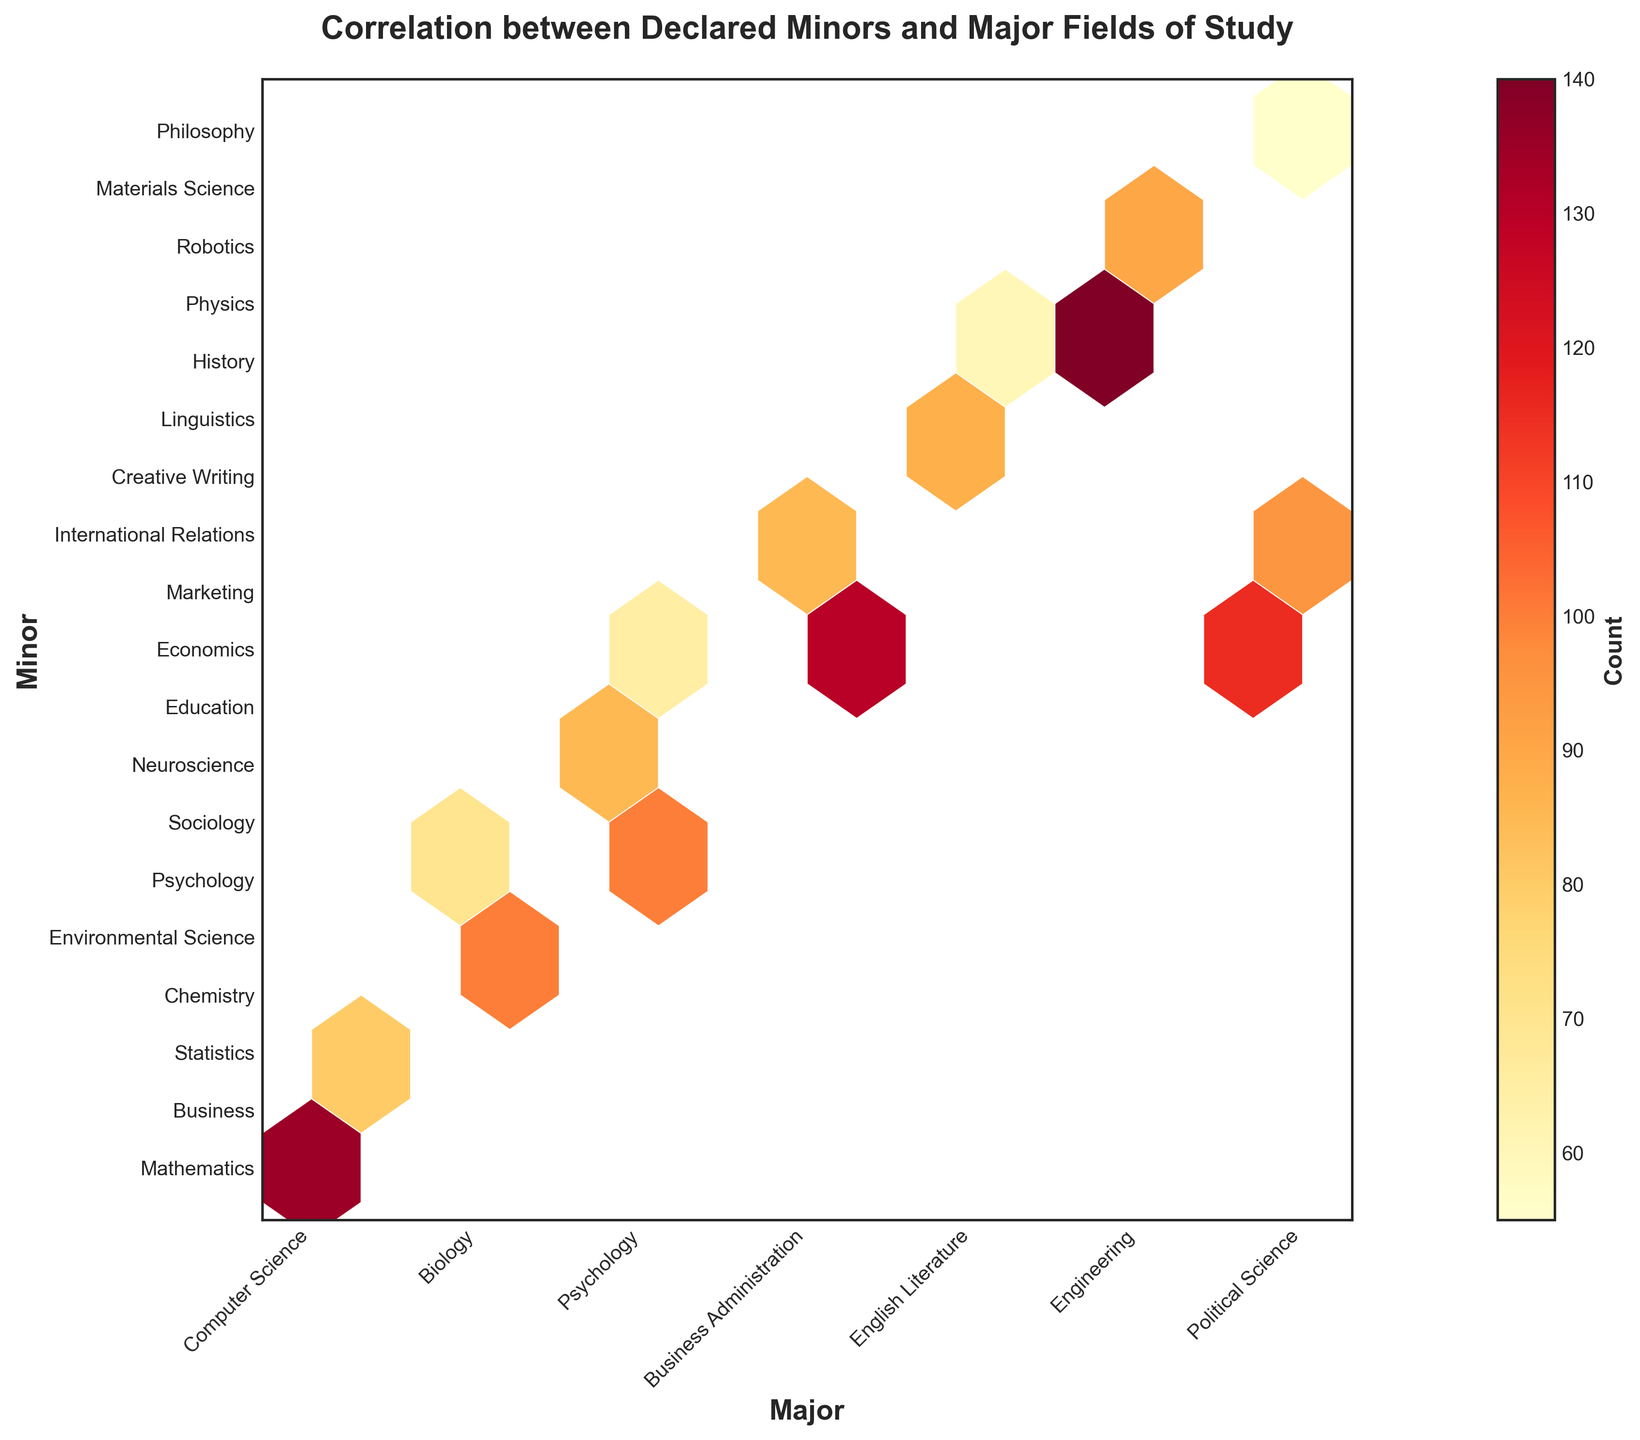What is the overall title of the plot? The overall title of the plot can be found at the top and typically describes the main subject of the plot. In this case, it reads "Correlation between Declared Minors and Major Fields of Study".
Answer: Correlation between Declared Minors and Major Fields of Study What do the colors in the hexagons represent? The colors in the hexagons on a hexbin plot represent the count of data points in that specific bin. The color gradient from light yellow to dark red indicates increasing counts, as shown in the colorbar.
Answer: Count of data points Which major and minor combination has the highest count? To determine this, locate the darkest hexagon on the plot and refer to the x and y axes labels. The darkest hexagon indicates the highest count.
Answer: Computer Science and Mathematics What axis represents the minors in the plot? The y-axis typically represents the dependent variables. In this plot, the y-axis labels are the minors, which indicate that it represents the declared minors.
Answer: y-axis Between Computer Science and Business Administration, which major has a higher count of students with Economics as a minor? Locate the hexagons for both Computer Science-Economics and Business Administration-Economics. The color intensity in the respective hexagons will indicate the counts. Compare them based on the color.
Answer: Business Administration How many majors and minors are displayed in the plot? Count the distinct labels on the x-axis and the y-axis. There are multiple labels on each axis representing different majors and minors.
Answer: 7 majors and 13 minors Which minor seems to be most frequently paired with the major Political Science? Check the hexagons along the x-axis label for Political Science and see which minor label along the y-axis corresponds to the hexagon with the darkest color.
Answer: Economics What is the count for the combination of Engineering and Robotics? Find the intersection of the Engineering label on the x-axis and Robotics on the y-axis. Check the color of the hexagon at this position against the colorbar to determine the count.
Answer: 100 Is Mathematics a popular minor for any major other than Computer Science? Look for the hexagons along the y-axis for Mathematics, noting their color intensity. Compare them with the intensity of the Computer Science-Mathematics hexagon.
Answer: No Between Business Administration and Political Science, which has more counts of students with International Relations as a minor? Locate the hexagons for Business Administration-International Relations and Political Science-International Relations. Compare the color intensities of these hexagons.
Answer: Political Science 